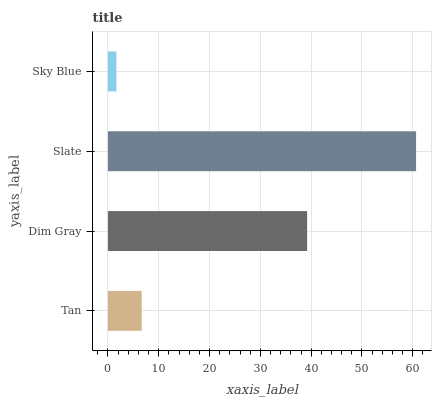Is Sky Blue the minimum?
Answer yes or no. Yes. Is Slate the maximum?
Answer yes or no. Yes. Is Dim Gray the minimum?
Answer yes or no. No. Is Dim Gray the maximum?
Answer yes or no. No. Is Dim Gray greater than Tan?
Answer yes or no. Yes. Is Tan less than Dim Gray?
Answer yes or no. Yes. Is Tan greater than Dim Gray?
Answer yes or no. No. Is Dim Gray less than Tan?
Answer yes or no. No. Is Dim Gray the high median?
Answer yes or no. Yes. Is Tan the low median?
Answer yes or no. Yes. Is Tan the high median?
Answer yes or no. No. Is Sky Blue the low median?
Answer yes or no. No. 